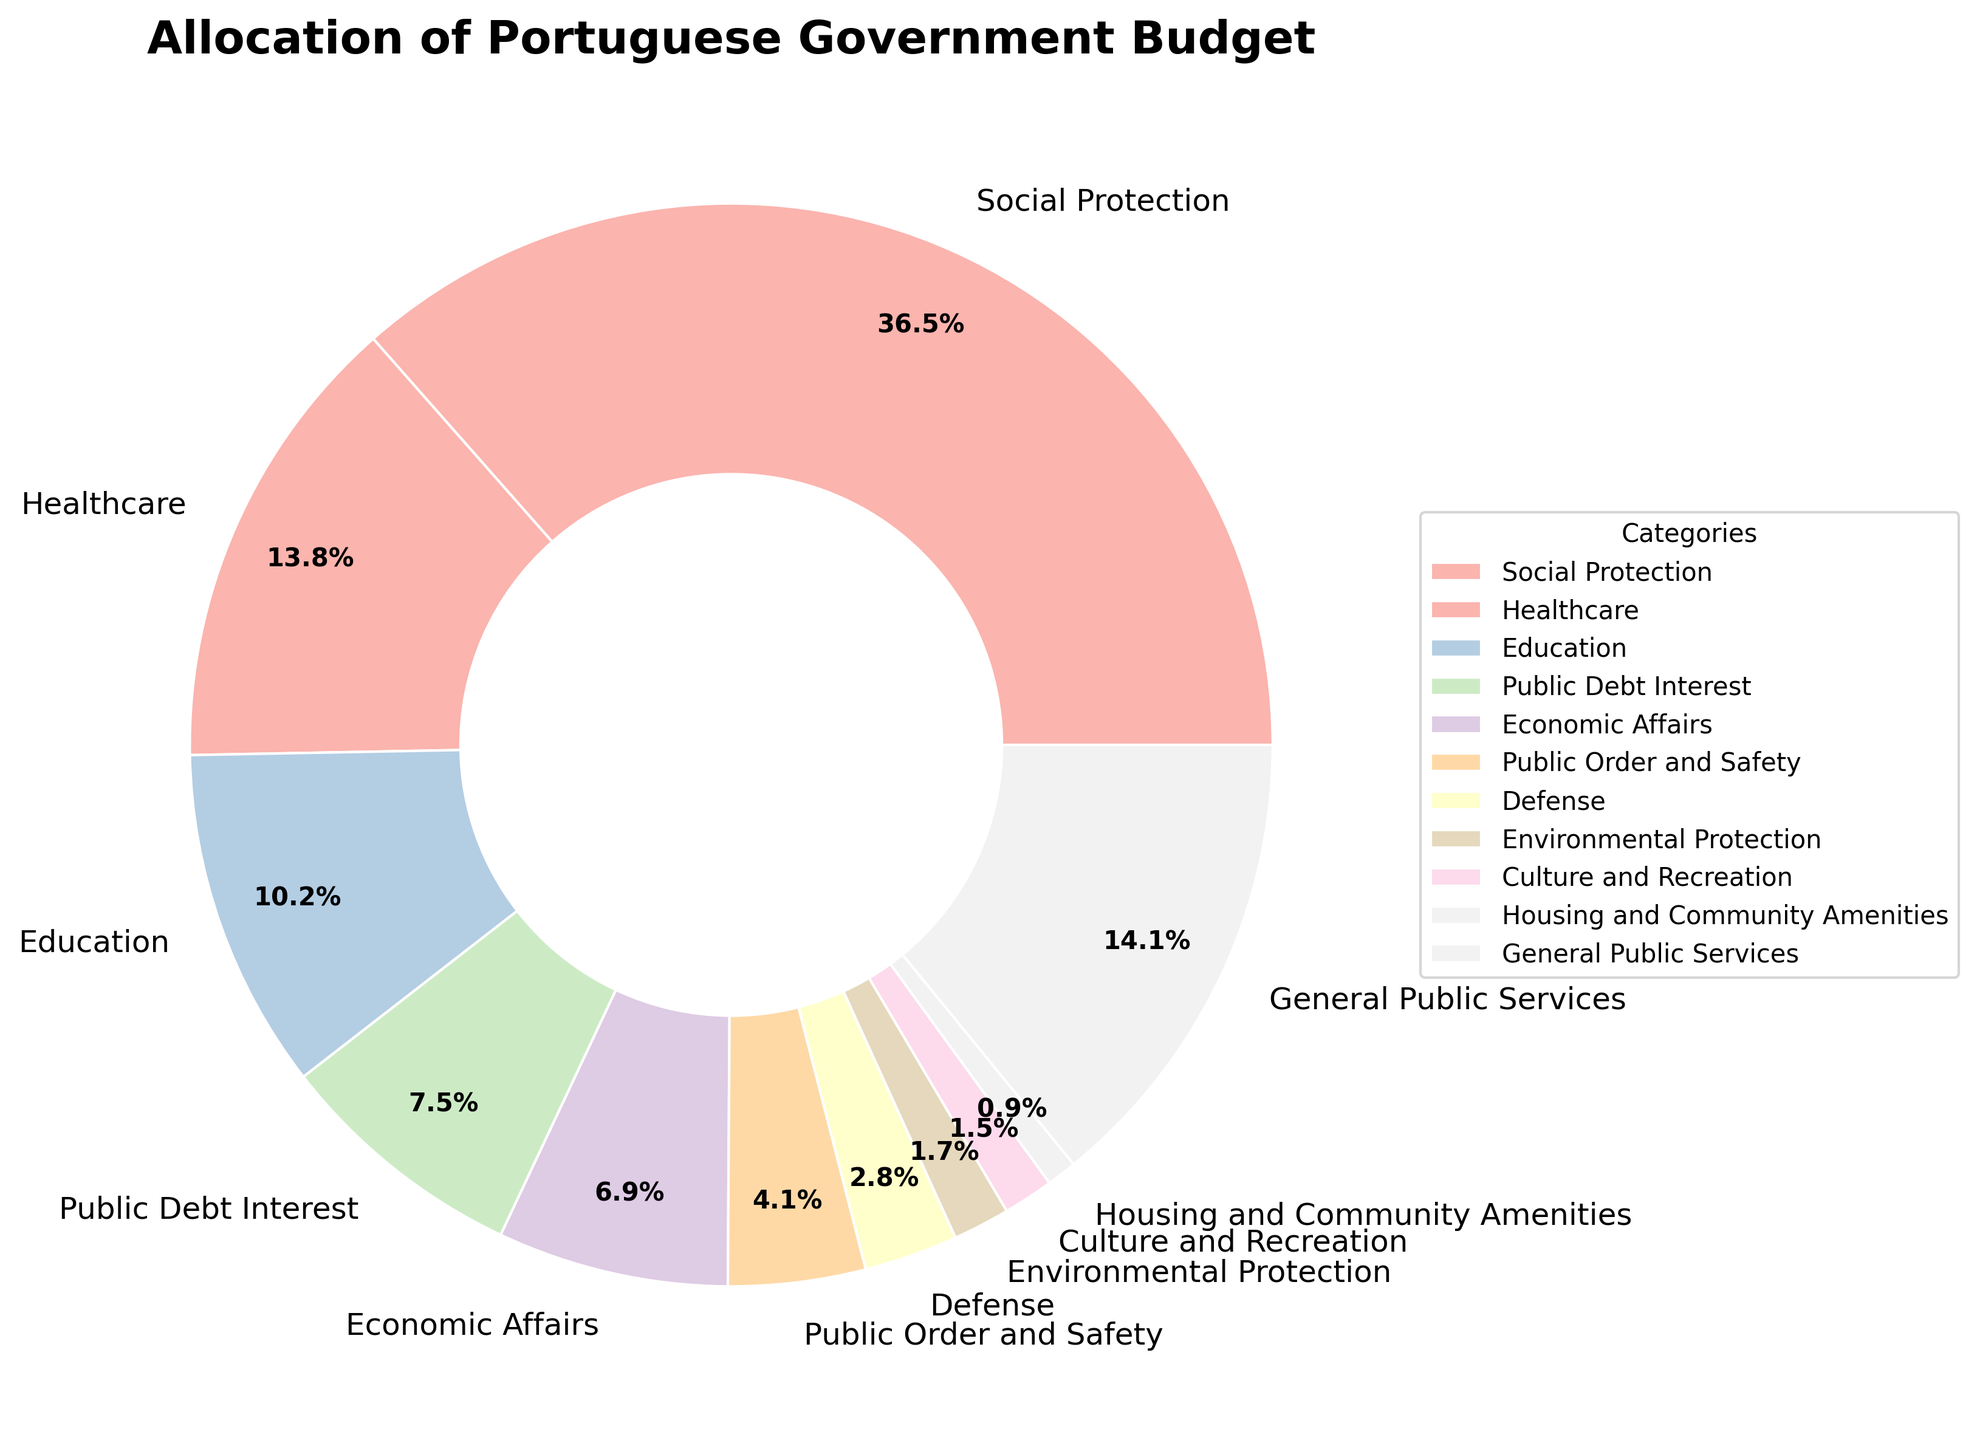What's the largest category in the pie chart? To find the largest category, look at the slice with the highest percentage. In the pie chart, "Social Protection" has the largest percentage which is 36.5%
Answer: Social Protection How does the percentage of Healthcare compare to that of Economic Affairs? For comparison, refer to the slices representing Healthcare and Economic Affairs. Healthcare has 13.8% and Economic Affairs has 6.9%. Healthcare is almost double the percentage of Economic Affairs
Answer: Healthcare is almost double Which two categories have the smallest share of the budget? Identify the two smallest slices in the pie chart. "Housing and Community Amenities" has 0.9% and "Culture and Recreation" has 1.5%
Answer: Housing and Community Amenities and Culture and Recreation What is the combined percentage of Education, Defense, and Public Order and Safety? To find the combined percentage, add the percentages of Education (10.2%), Defense (2.8%), and Public Order and Safety (4.1%): 10.2% + 2.8% + 4.1% = 17.1%
Answer: 17.1% Which categories have a higher allocation than General Public Services? General Public Services has 14.1%. Compare it with other percentages. Only "Social Protection" at 36.5% has a higher allocation
Answer: Social Protection What is the percentage difference between Social Protection and Public Debt Interest? Subtract the percentage of Public Debt Interest (7.5%) from Social Protection (36.5%): 36.5% - 7.5% = 29%
Answer: 29% How much larger is the category of Social Protection compared to Education in percentage points? Subtract the percentage of Education (10.2%) from Social Protection (36.5%): 36.5% - 10.2% = 26.3%
Answer: 26.3% Which category has a slightly lower percentage allocation than General Public Services? Look at the categories close to 14.1%. Healthcare has 13.8%, which is slightly lower than General Public Services
Answer: Healthcare Is the percentage of Environmental Protection more or less than 2%? Observe the value for Environmental Protection, which is shown as 1.7%. This is less than 2%
Answer: Less What's the second-largest category in the budget allocation? After identifying the largest (Social Protection at 36.5%), look for the next largest slice. The second largest is General Public Services at 14.1%
Answer: General Public Services 